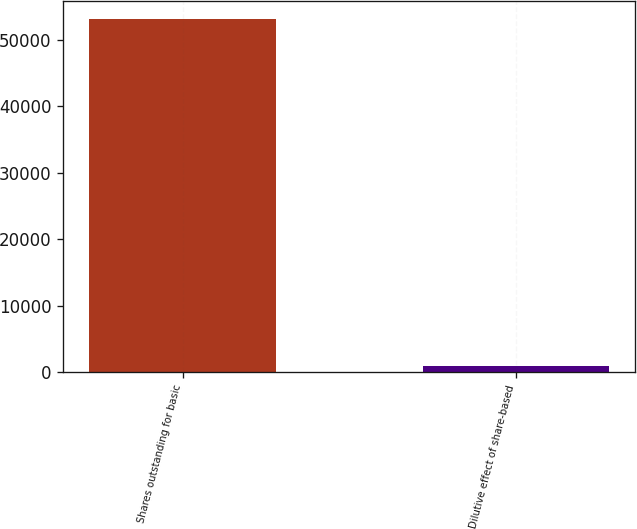<chart> <loc_0><loc_0><loc_500><loc_500><bar_chart><fcel>Shares outstanding for basic<fcel>Dilutive effect of share-based<nl><fcel>53159<fcel>826<nl></chart> 